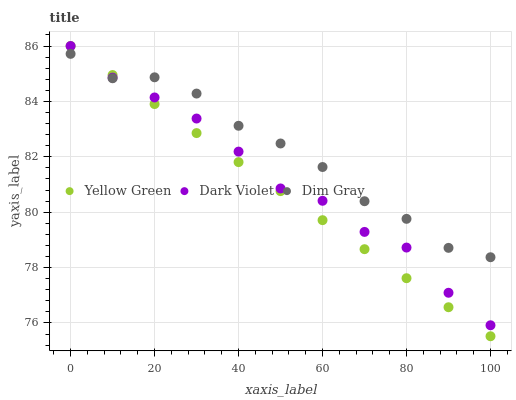Does Yellow Green have the minimum area under the curve?
Answer yes or no. Yes. Does Dim Gray have the maximum area under the curve?
Answer yes or no. Yes. Does Dark Violet have the minimum area under the curve?
Answer yes or no. No. Does Dark Violet have the maximum area under the curve?
Answer yes or no. No. Is Yellow Green the smoothest?
Answer yes or no. Yes. Is Dim Gray the roughest?
Answer yes or no. Yes. Is Dark Violet the smoothest?
Answer yes or no. No. Is Dark Violet the roughest?
Answer yes or no. No. Does Yellow Green have the lowest value?
Answer yes or no. Yes. Does Dark Violet have the lowest value?
Answer yes or no. No. Does Dark Violet have the highest value?
Answer yes or no. Yes. Does Dark Violet intersect Yellow Green?
Answer yes or no. Yes. Is Dark Violet less than Yellow Green?
Answer yes or no. No. Is Dark Violet greater than Yellow Green?
Answer yes or no. No. 